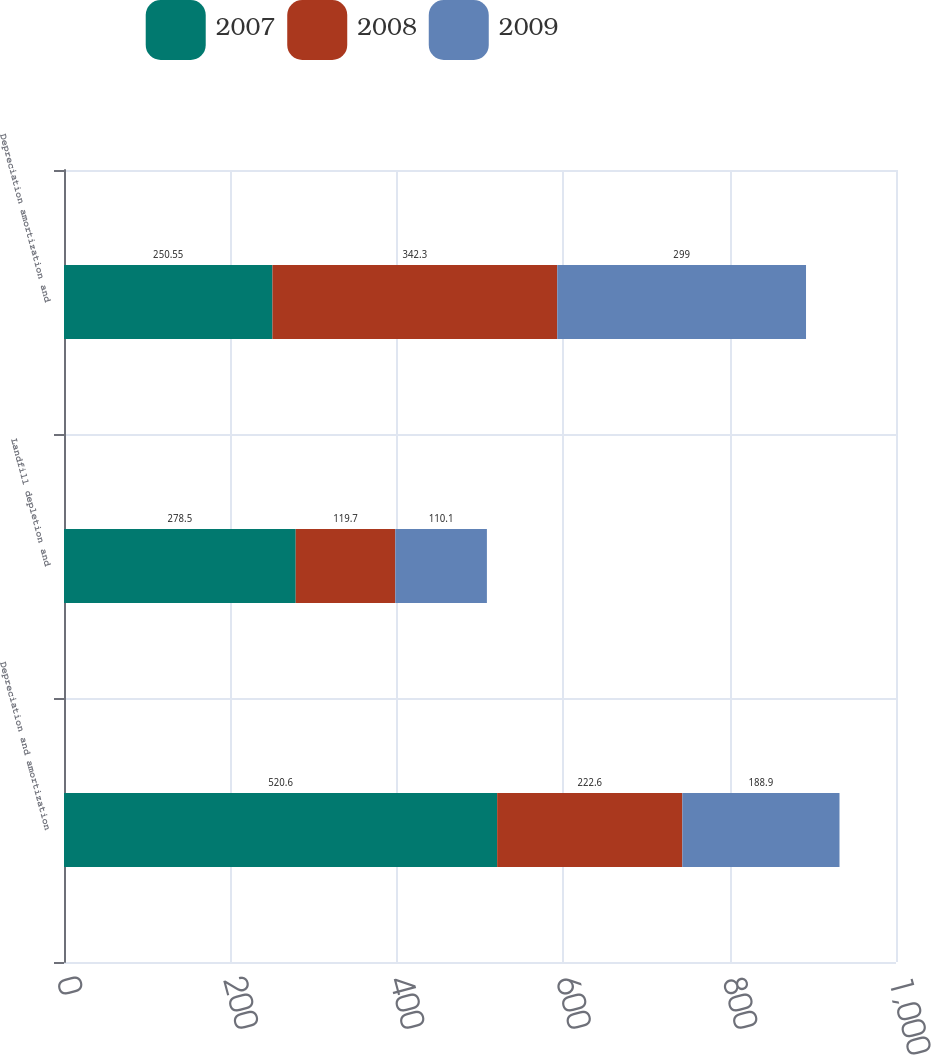<chart> <loc_0><loc_0><loc_500><loc_500><stacked_bar_chart><ecel><fcel>Depreciation and amortization<fcel>Landfill depletion and<fcel>Depreciation amortization and<nl><fcel>2007<fcel>520.6<fcel>278.5<fcel>250.55<nl><fcel>2008<fcel>222.6<fcel>119.7<fcel>342.3<nl><fcel>2009<fcel>188.9<fcel>110.1<fcel>299<nl></chart> 